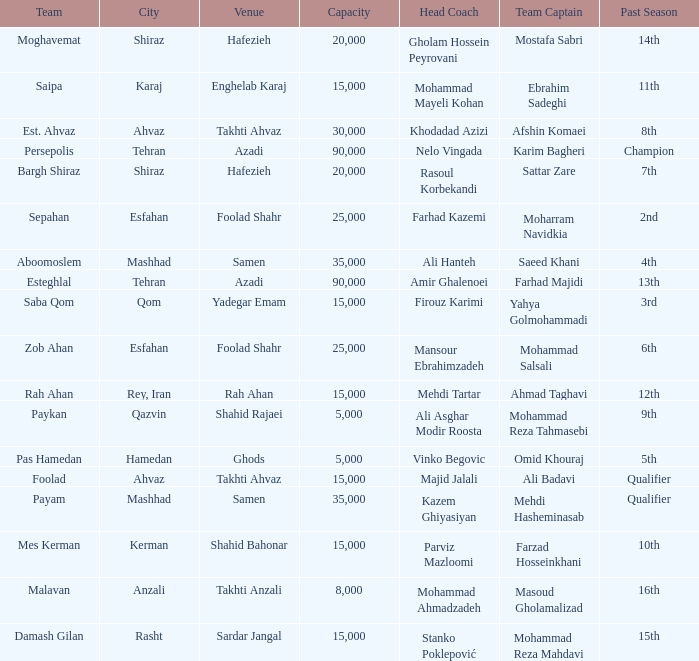Can you parse all the data within this table? {'header': ['Team', 'City', 'Venue', 'Capacity', 'Head Coach', 'Team Captain', 'Past Season'], 'rows': [['Moghavemat', 'Shiraz', 'Hafezieh', '20,000', 'Gholam Hossein Peyrovani', 'Mostafa Sabri', '14th'], ['Saipa', 'Karaj', 'Enghelab Karaj', '15,000', 'Mohammad Mayeli Kohan', 'Ebrahim Sadeghi', '11th'], ['Est. Ahvaz', 'Ahvaz', 'Takhti Ahvaz', '30,000', 'Khodadad Azizi', 'Afshin Komaei', '8th'], ['Persepolis', 'Tehran', 'Azadi', '90,000', 'Nelo Vingada', 'Karim Bagheri', 'Champion'], ['Bargh Shiraz', 'Shiraz', 'Hafezieh', '20,000', 'Rasoul Korbekandi', 'Sattar Zare', '7th'], ['Sepahan', 'Esfahan', 'Foolad Shahr', '25,000', 'Farhad Kazemi', 'Moharram Navidkia', '2nd'], ['Aboomoslem', 'Mashhad', 'Samen', '35,000', 'Ali Hanteh', 'Saeed Khani', '4th'], ['Esteghlal', 'Tehran', 'Azadi', '90,000', 'Amir Ghalenoei', 'Farhad Majidi', '13th'], ['Saba Qom', 'Qom', 'Yadegar Emam', '15,000', 'Firouz Karimi', 'Yahya Golmohammadi', '3rd'], ['Zob Ahan', 'Esfahan', 'Foolad Shahr', '25,000', 'Mansour Ebrahimzadeh', 'Mohammad Salsali', '6th'], ['Rah Ahan', 'Rey, Iran', 'Rah Ahan', '15,000', 'Mehdi Tartar', 'Ahmad Taghavi', '12th'], ['Paykan', 'Qazvin', 'Shahid Rajaei', '5,000', 'Ali Asghar Modir Roosta', 'Mohammad Reza Tahmasebi', '9th'], ['Pas Hamedan', 'Hamedan', 'Ghods', '5,000', 'Vinko Begovic', 'Omid Khouraj', '5th'], ['Foolad', 'Ahvaz', 'Takhti Ahvaz', '15,000', 'Majid Jalali', 'Ali Badavi', 'Qualifier'], ['Payam', 'Mashhad', 'Samen', '35,000', 'Kazem Ghiyasiyan', 'Mehdi Hasheminasab', 'Qualifier'], ['Mes Kerman', 'Kerman', 'Shahid Bahonar', '15,000', 'Parviz Mazloomi', 'Farzad Hosseinkhani', '10th'], ['Malavan', 'Anzali', 'Takhti Anzali', '8,000', 'Mohammad Ahmadzadeh', 'Masoud Gholamalizad', '16th'], ['Damash Gilan', 'Rasht', 'Sardar Jangal', '15,000', 'Stanko Poklepović', 'Mohammad Reza Mahdavi', '15th']]} At which location was there a past season with a 2nd place finish? Foolad Shahr. 